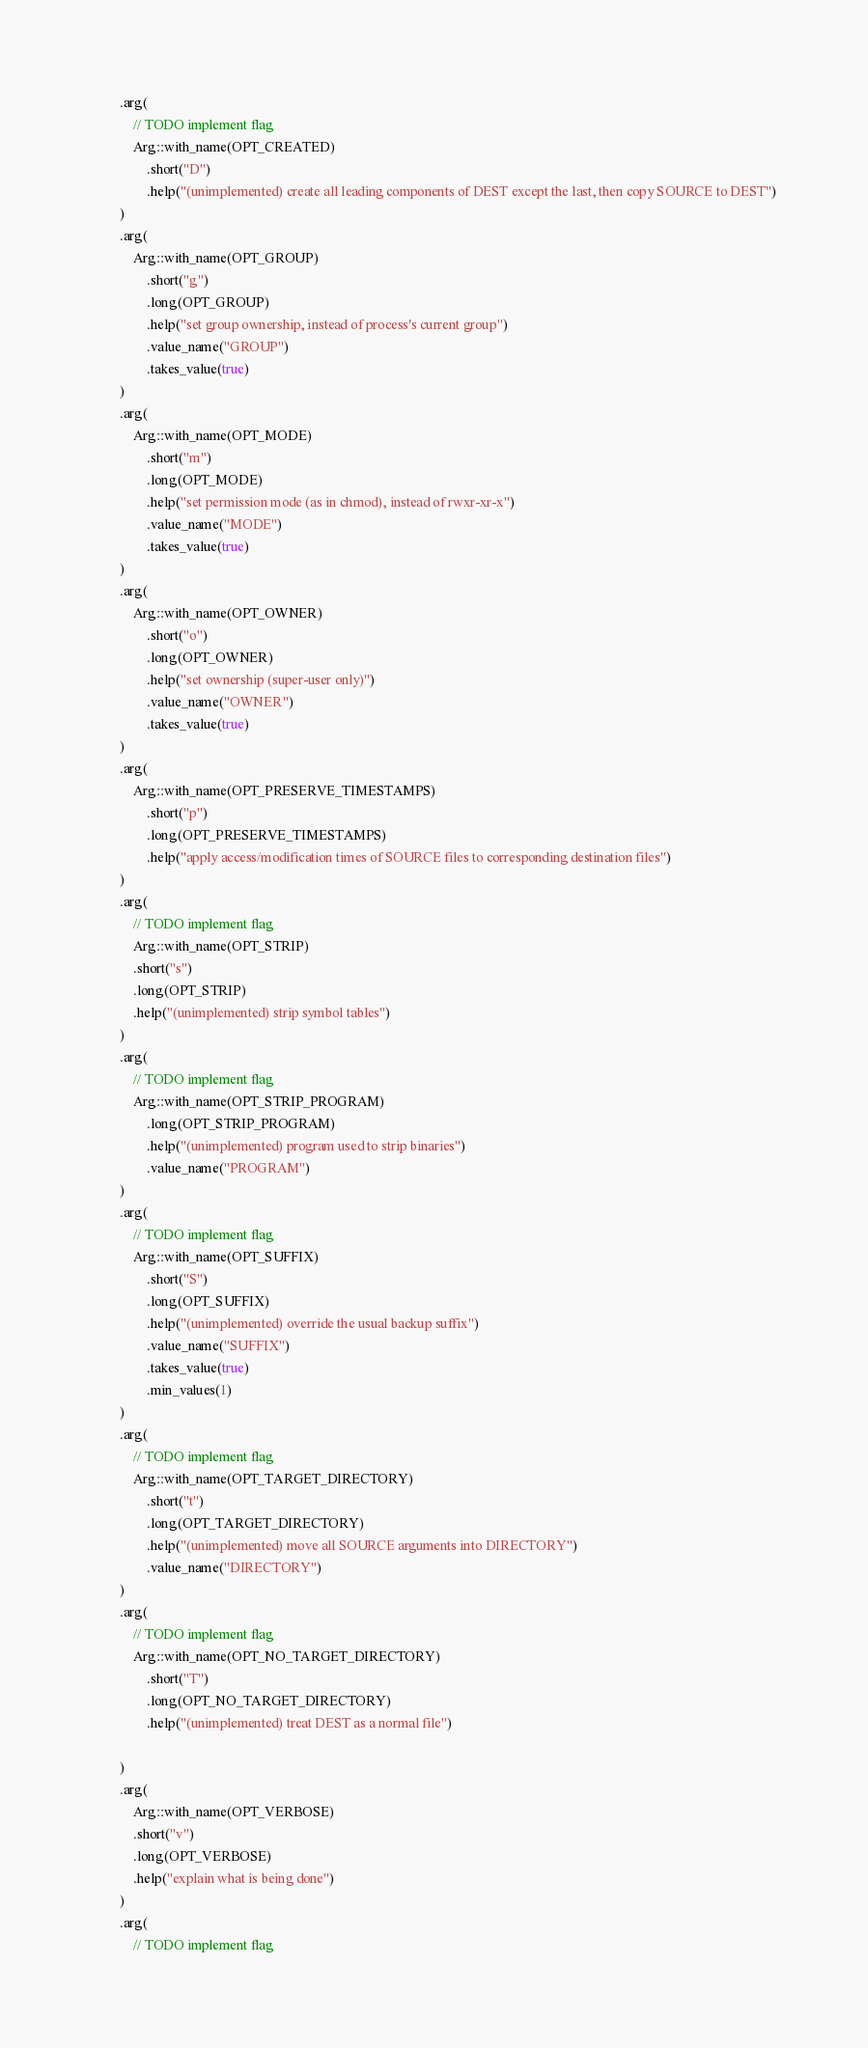Convert code to text. <code><loc_0><loc_0><loc_500><loc_500><_Rust_>        .arg(
            // TODO implement flag
            Arg::with_name(OPT_CREATED)
                .short("D")
                .help("(unimplemented) create all leading components of DEST except the last, then copy SOURCE to DEST")
        )
        .arg(
            Arg::with_name(OPT_GROUP)
                .short("g")
                .long(OPT_GROUP)
                .help("set group ownership, instead of process's current group")
                .value_name("GROUP")
                .takes_value(true)
        )
        .arg(
            Arg::with_name(OPT_MODE)
                .short("m")
                .long(OPT_MODE)
                .help("set permission mode (as in chmod), instead of rwxr-xr-x")
                .value_name("MODE")
                .takes_value(true)
        )
        .arg(
            Arg::with_name(OPT_OWNER)
                .short("o")
                .long(OPT_OWNER)
                .help("set ownership (super-user only)")
                .value_name("OWNER")
                .takes_value(true)
        )
        .arg(
            Arg::with_name(OPT_PRESERVE_TIMESTAMPS)
                .short("p")
                .long(OPT_PRESERVE_TIMESTAMPS)
                .help("apply access/modification times of SOURCE files to corresponding destination files")
        )
        .arg(
            // TODO implement flag
            Arg::with_name(OPT_STRIP)
            .short("s")
            .long(OPT_STRIP)
            .help("(unimplemented) strip symbol tables")
        )
        .arg(
            // TODO implement flag
            Arg::with_name(OPT_STRIP_PROGRAM)
                .long(OPT_STRIP_PROGRAM)
                .help("(unimplemented) program used to strip binaries")
                .value_name("PROGRAM")
        )
        .arg(
            // TODO implement flag
            Arg::with_name(OPT_SUFFIX)
                .short("S")
                .long(OPT_SUFFIX)
                .help("(unimplemented) override the usual backup suffix")
                .value_name("SUFFIX")
                .takes_value(true)
                .min_values(1)
        )
        .arg(
            // TODO implement flag
            Arg::with_name(OPT_TARGET_DIRECTORY)
                .short("t")
                .long(OPT_TARGET_DIRECTORY)
                .help("(unimplemented) move all SOURCE arguments into DIRECTORY")
                .value_name("DIRECTORY")
        )
        .arg(
            // TODO implement flag
            Arg::with_name(OPT_NO_TARGET_DIRECTORY)
                .short("T")
                .long(OPT_NO_TARGET_DIRECTORY)
                .help("(unimplemented) treat DEST as a normal file")

        )
        .arg(
            Arg::with_name(OPT_VERBOSE)
            .short("v")
            .long(OPT_VERBOSE)
            .help("explain what is being done")
        )
        .arg(
            // TODO implement flag</code> 